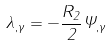Convert formula to latex. <formula><loc_0><loc_0><loc_500><loc_500>\lambda _ { , \gamma } = - \frac { R _ { 2 } } 2 \Psi _ { , \gamma }</formula> 